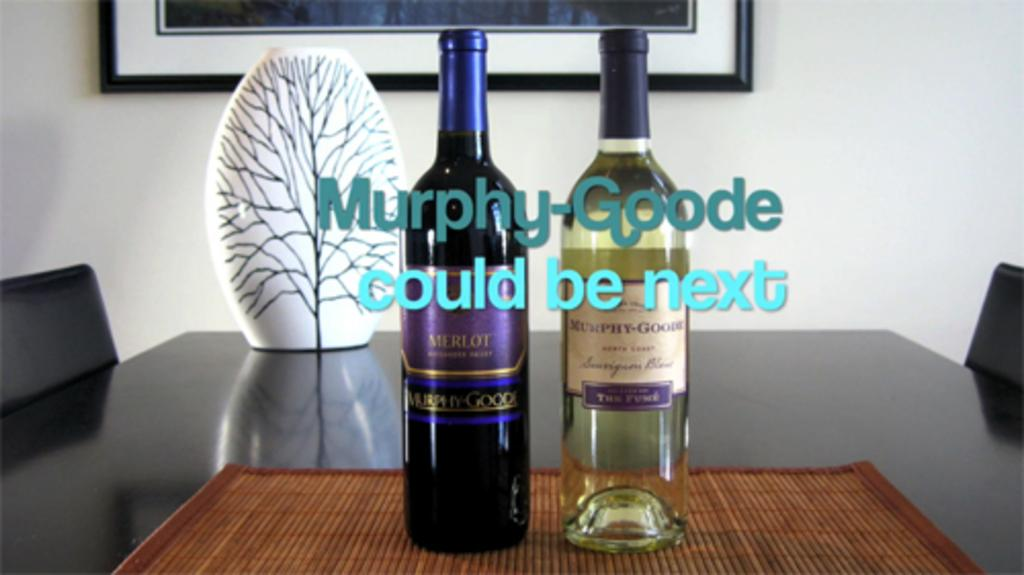<image>
Share a concise interpretation of the image provided. Two bottles of Murphy Goode are setting on a table. 